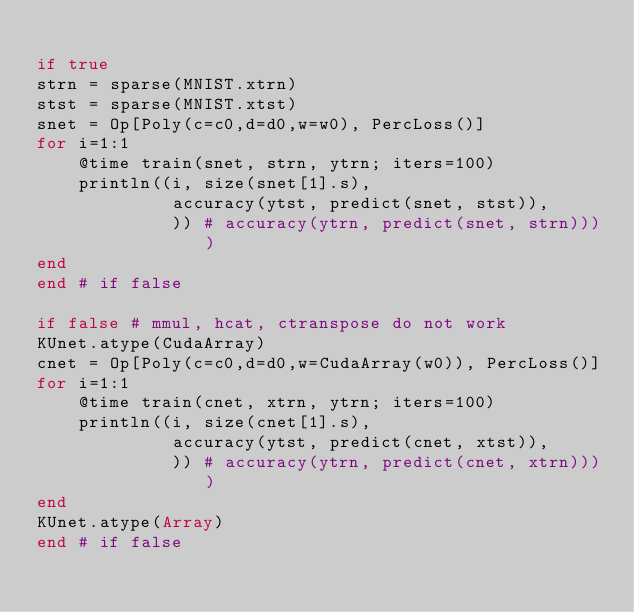Convert code to text. <code><loc_0><loc_0><loc_500><loc_500><_Julia_>
if true
strn = sparse(MNIST.xtrn)
stst = sparse(MNIST.xtst)
snet = Op[Poly(c=c0,d=d0,w=w0), PercLoss()]
for i=1:1
    @time train(snet, strn, ytrn; iters=100)
    println((i, size(snet[1].s), 
             accuracy(ytst, predict(snet, stst)),
             )) # accuracy(ytrn, predict(snet, strn))))
end
end # if false

if false # mmul, hcat, ctranspose do not work
KUnet.atype(CudaArray)
cnet = Op[Poly(c=c0,d=d0,w=CudaArray(w0)), PercLoss()]
for i=1:1
    @time train(cnet, xtrn, ytrn; iters=100)
    println((i, size(cnet[1].s), 
             accuracy(ytst, predict(cnet, xtst)),
             )) # accuracy(ytrn, predict(cnet, xtrn))))
end
KUnet.atype(Array)
end # if false
</code> 